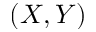Convert formula to latex. <formula><loc_0><loc_0><loc_500><loc_500>( X , Y )</formula> 